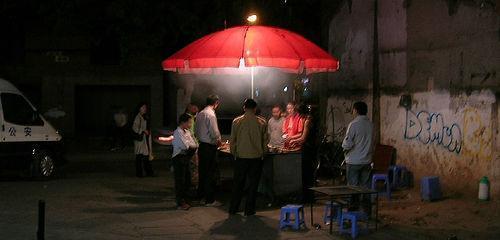How many people are in this picture?
Give a very brief answer. 8. 